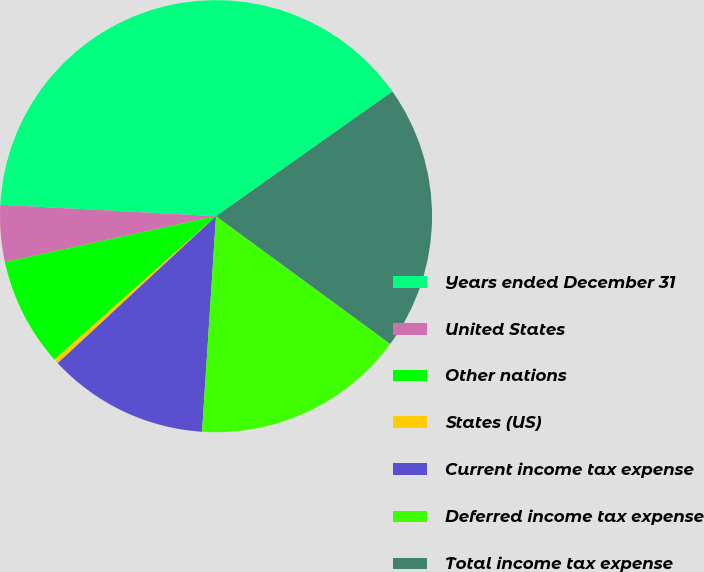Convert chart to OTSL. <chart><loc_0><loc_0><loc_500><loc_500><pie_chart><fcel>Years ended December 31<fcel>United States<fcel>Other nations<fcel>States (US)<fcel>Current income tax expense<fcel>Deferred income tax expense<fcel>Total income tax expense<nl><fcel>39.37%<fcel>4.25%<fcel>8.15%<fcel>0.35%<fcel>12.06%<fcel>15.96%<fcel>19.86%<nl></chart> 